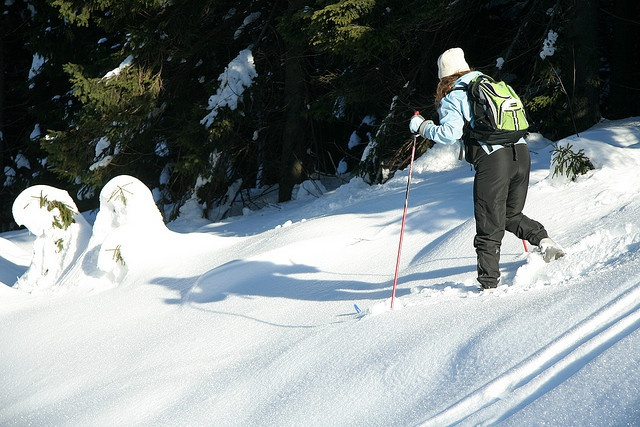Describe the objects in this image and their specific colors. I can see people in black, gray, white, and darkgray tones and backpack in black, white, khaki, and gray tones in this image. 